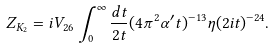Convert formula to latex. <formula><loc_0><loc_0><loc_500><loc_500>Z _ { K _ { 2 } } = i V _ { 2 6 } \int _ { 0 } ^ { \infty } \frac { d t } { 2 t } ( 4 \pi ^ { 2 } \alpha ^ { \prime } t ) ^ { - 1 3 } \eta ( 2 i t ) ^ { - 2 4 } .</formula> 